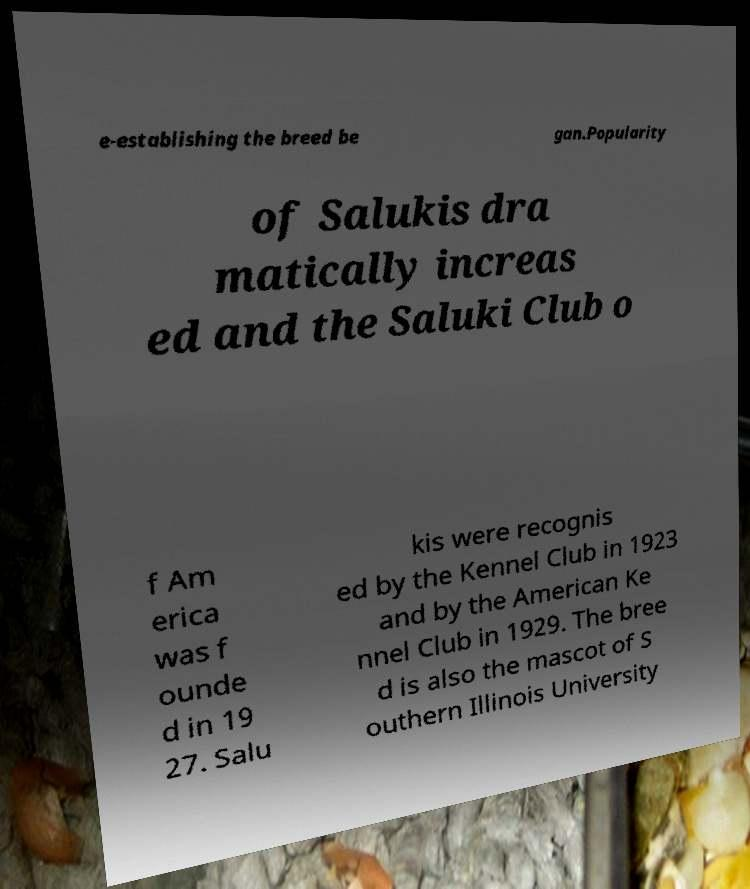Please identify and transcribe the text found in this image. e-establishing the breed be gan.Popularity of Salukis dra matically increas ed and the Saluki Club o f Am erica was f ounde d in 19 27. Salu kis were recognis ed by the Kennel Club in 1923 and by the American Ke nnel Club in 1929. The bree d is also the mascot of S outhern Illinois University 